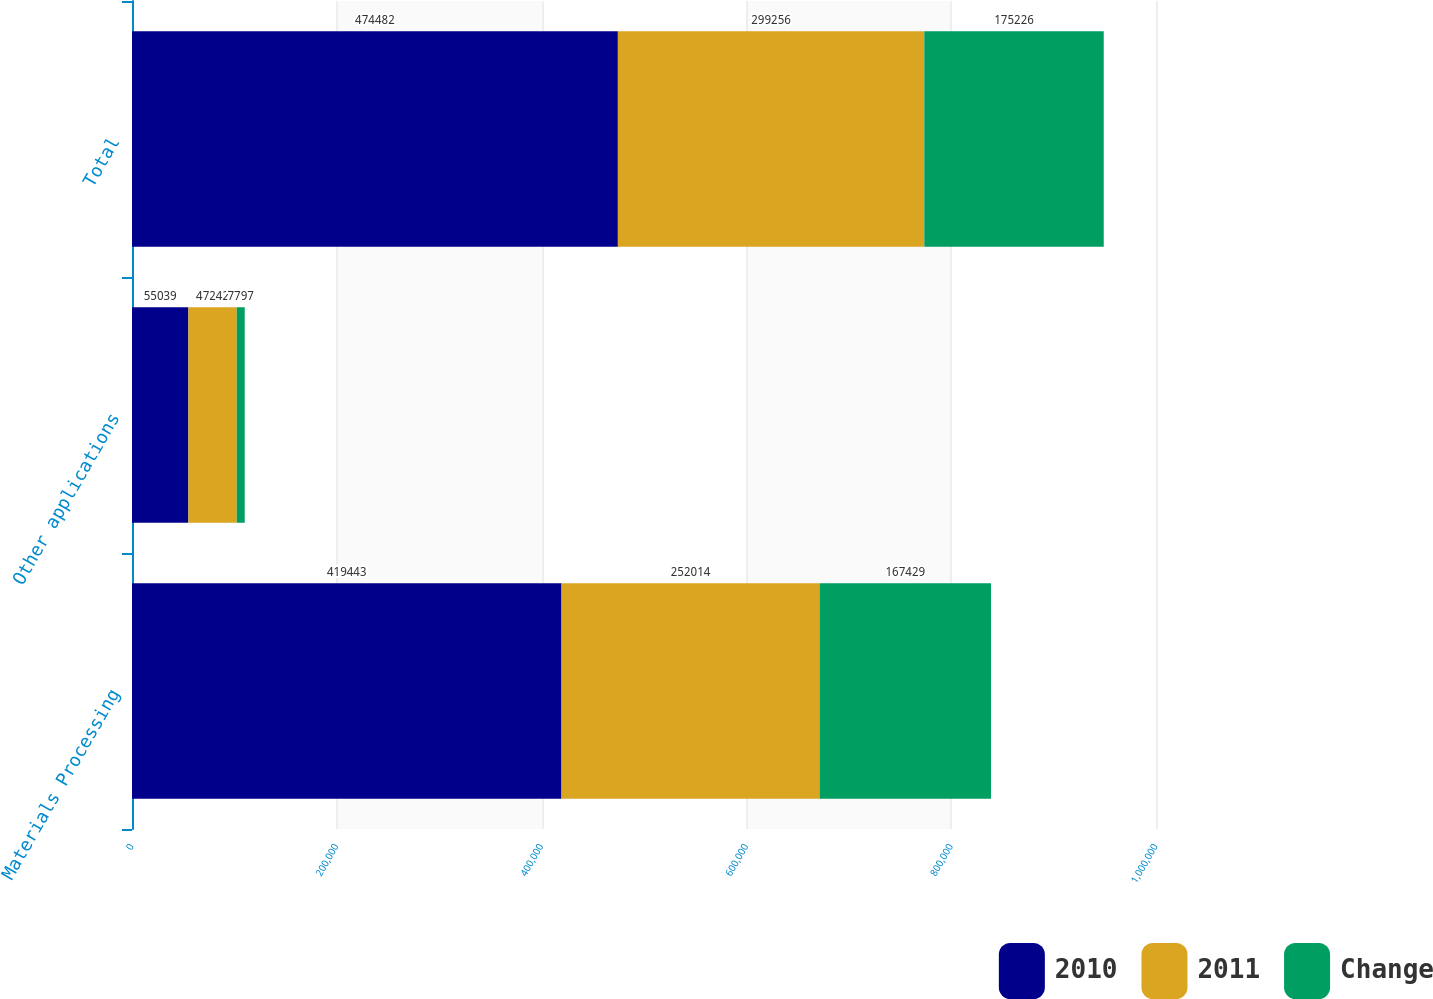Convert chart. <chart><loc_0><loc_0><loc_500><loc_500><stacked_bar_chart><ecel><fcel>Materials Processing<fcel>Other applications<fcel>Total<nl><fcel>2010<fcel>419443<fcel>55039<fcel>474482<nl><fcel>2011<fcel>252014<fcel>47242<fcel>299256<nl><fcel>Change<fcel>167429<fcel>7797<fcel>175226<nl></chart> 